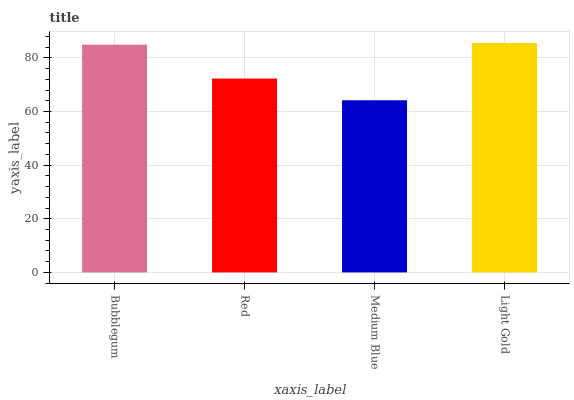Is Medium Blue the minimum?
Answer yes or no. Yes. Is Light Gold the maximum?
Answer yes or no. Yes. Is Red the minimum?
Answer yes or no. No. Is Red the maximum?
Answer yes or no. No. Is Bubblegum greater than Red?
Answer yes or no. Yes. Is Red less than Bubblegum?
Answer yes or no. Yes. Is Red greater than Bubblegum?
Answer yes or no. No. Is Bubblegum less than Red?
Answer yes or no. No. Is Bubblegum the high median?
Answer yes or no. Yes. Is Red the low median?
Answer yes or no. Yes. Is Red the high median?
Answer yes or no. No. Is Bubblegum the low median?
Answer yes or no. No. 